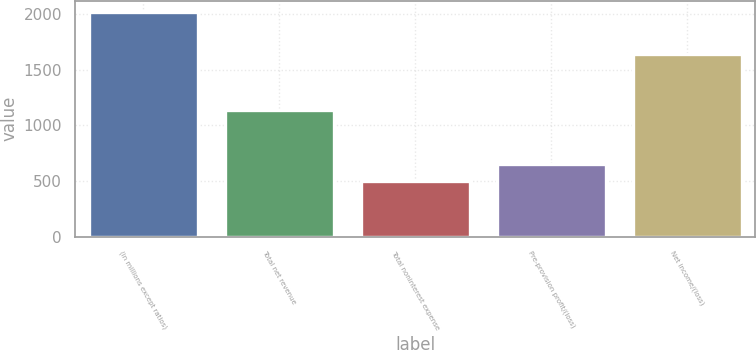Convert chart to OTSL. <chart><loc_0><loc_0><loc_500><loc_500><bar_chart><fcel>(in millions except ratios)<fcel>Total net revenue<fcel>Total noninterest expense<fcel>Pre-provision profit/(loss)<fcel>Net income/(loss)<nl><fcel>2017<fcel>1140<fcel>501<fcel>652.6<fcel>1643<nl></chart> 